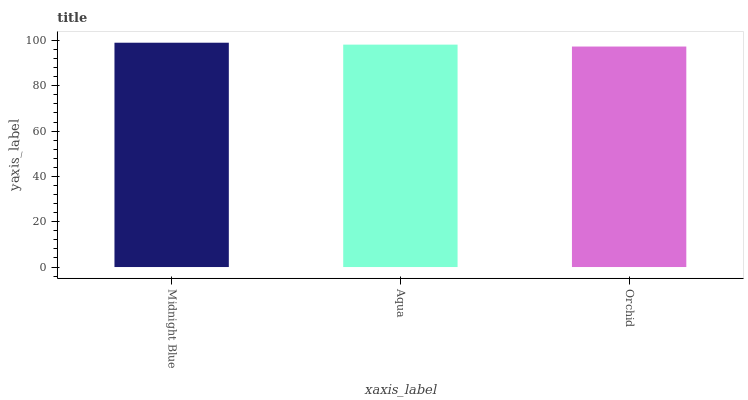Is Aqua the minimum?
Answer yes or no. No. Is Aqua the maximum?
Answer yes or no. No. Is Midnight Blue greater than Aqua?
Answer yes or no. Yes. Is Aqua less than Midnight Blue?
Answer yes or no. Yes. Is Aqua greater than Midnight Blue?
Answer yes or no. No. Is Midnight Blue less than Aqua?
Answer yes or no. No. Is Aqua the high median?
Answer yes or no. Yes. Is Aqua the low median?
Answer yes or no. Yes. Is Orchid the high median?
Answer yes or no. No. Is Midnight Blue the low median?
Answer yes or no. No. 